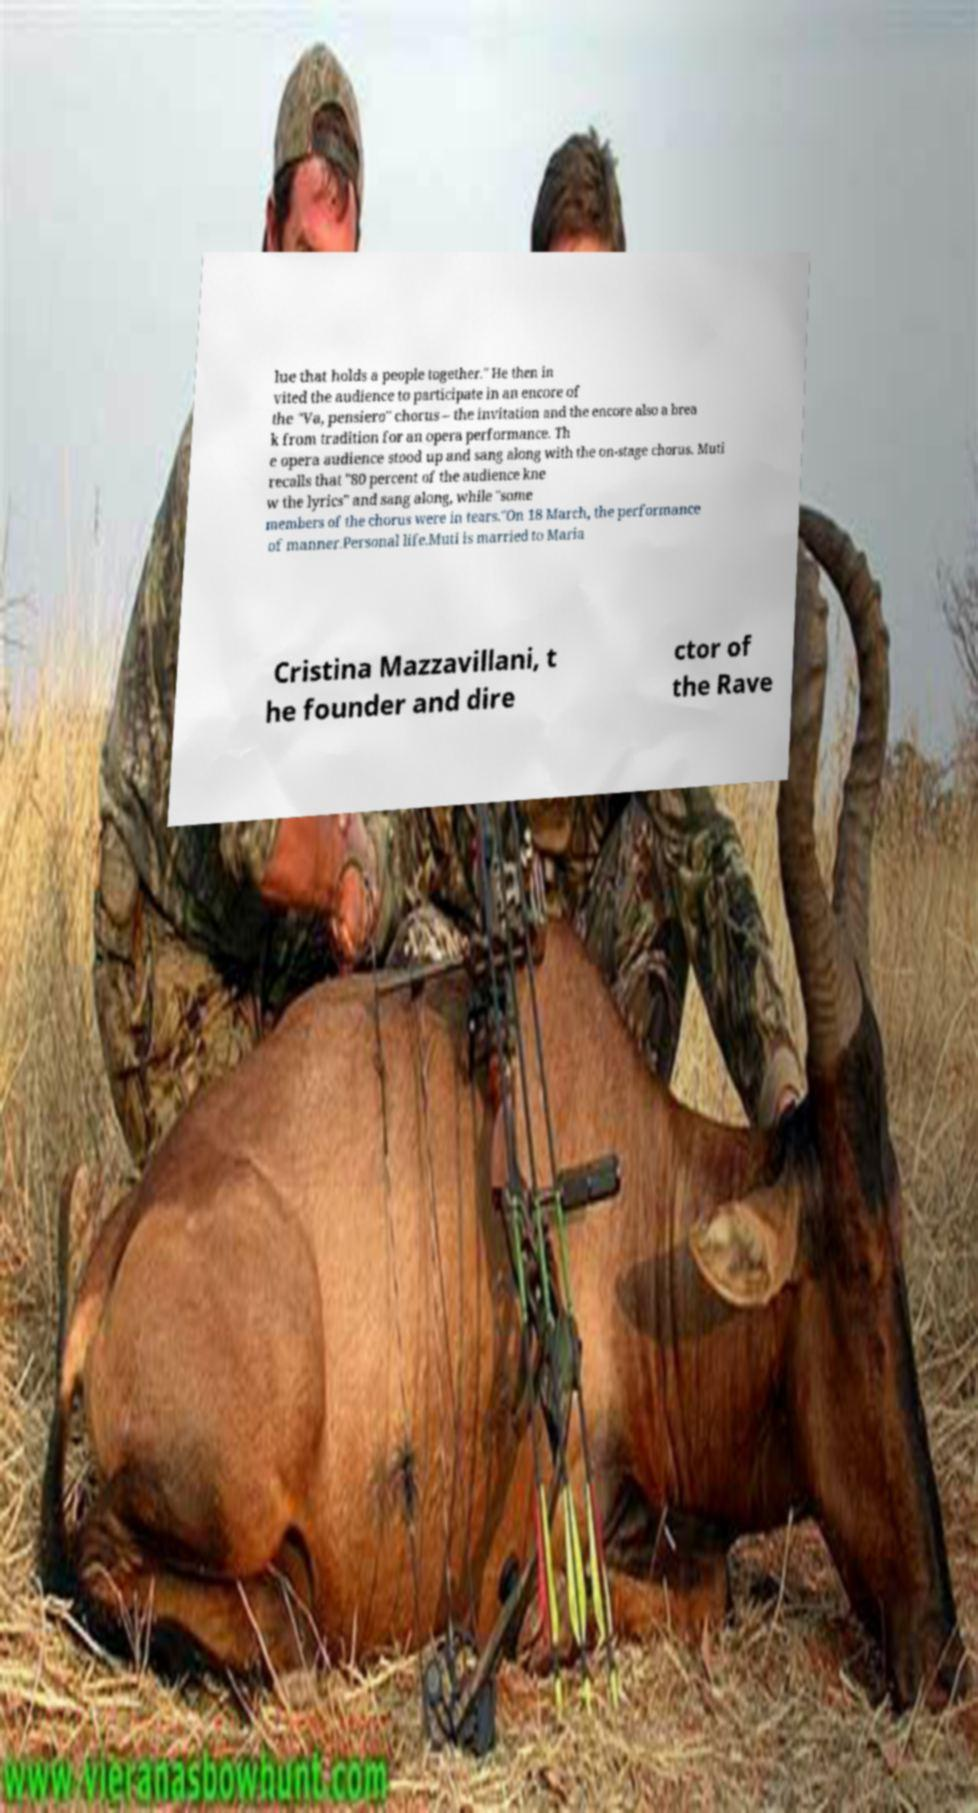Please read and relay the text visible in this image. What does it say? lue that holds a people together." He then in vited the audience to participate in an encore of the "Va, pensiero" chorus – the invitation and the encore also a brea k from tradition for an opera performance. Th e opera audience stood up and sang along with the on-stage chorus. Muti recalls that "80 percent of the audience kne w the lyrics" and sang along, while "some members of the chorus were in tears."On 18 March, the performance of manner.Personal life.Muti is married to Maria Cristina Mazzavillani, t he founder and dire ctor of the Rave 